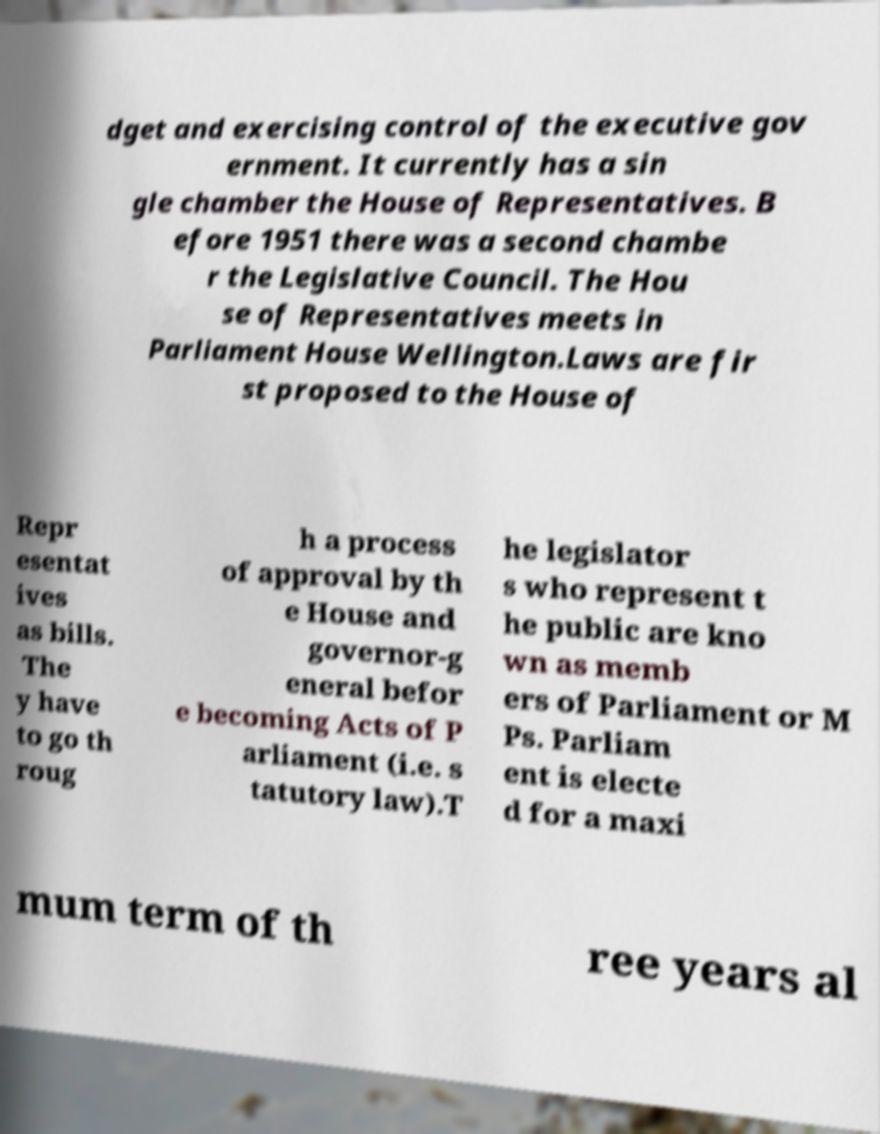Can you accurately transcribe the text from the provided image for me? dget and exercising control of the executive gov ernment. It currently has a sin gle chamber the House of Representatives. B efore 1951 there was a second chambe r the Legislative Council. The Hou se of Representatives meets in Parliament House Wellington.Laws are fir st proposed to the House of Repr esentat ives as bills. The y have to go th roug h a process of approval by th e House and governor-g eneral befor e becoming Acts of P arliament (i.e. s tatutory law).T he legislator s who represent t he public are kno wn as memb ers of Parliament or M Ps. Parliam ent is electe d for a maxi mum term of th ree years al 